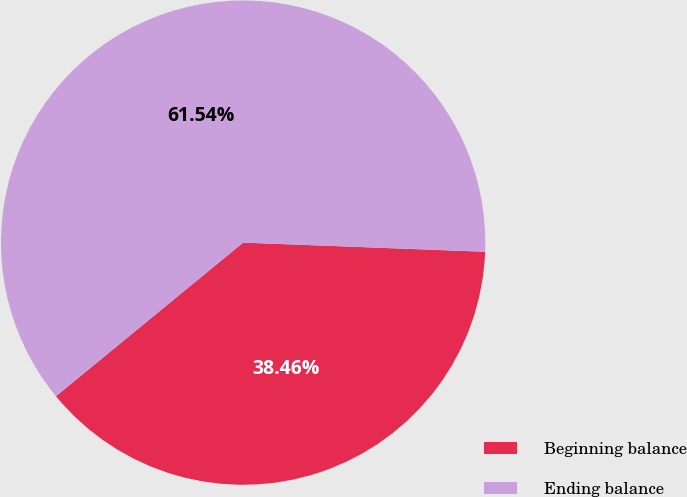Convert chart to OTSL. <chart><loc_0><loc_0><loc_500><loc_500><pie_chart><fcel>Beginning balance<fcel>Ending balance<nl><fcel>38.46%<fcel>61.54%<nl></chart> 